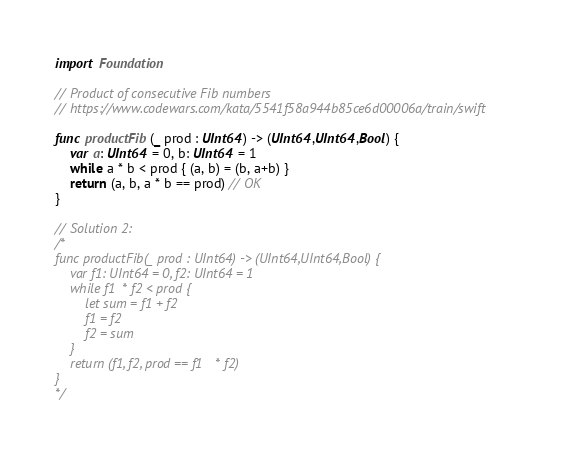<code> <loc_0><loc_0><loc_500><loc_500><_Swift_>import Foundation

// Product of consecutive Fib numbers
// https://www.codewars.com/kata/5541f58a944b85ce6d00006a/train/swift

func productFib(_ prod : UInt64) -> (UInt64,UInt64,Bool) {
    var a: UInt64 = 0, b: UInt64 = 1
    while a * b < prod { (a, b) = (b, a+b) }
    return (a, b, a * b == prod) // OK
}

// Solution 2:
/*
func productFib(_ prod : UInt64) -> (UInt64,UInt64,Bool) {
    var f1: UInt64 = 0, f2: UInt64 = 1
    while f1 * f2 < prod {
        let sum = f1 + f2
        f1 = f2
        f2 = sum
    }
    return (f1, f2, prod == f1 * f2)
}
*/
</code> 